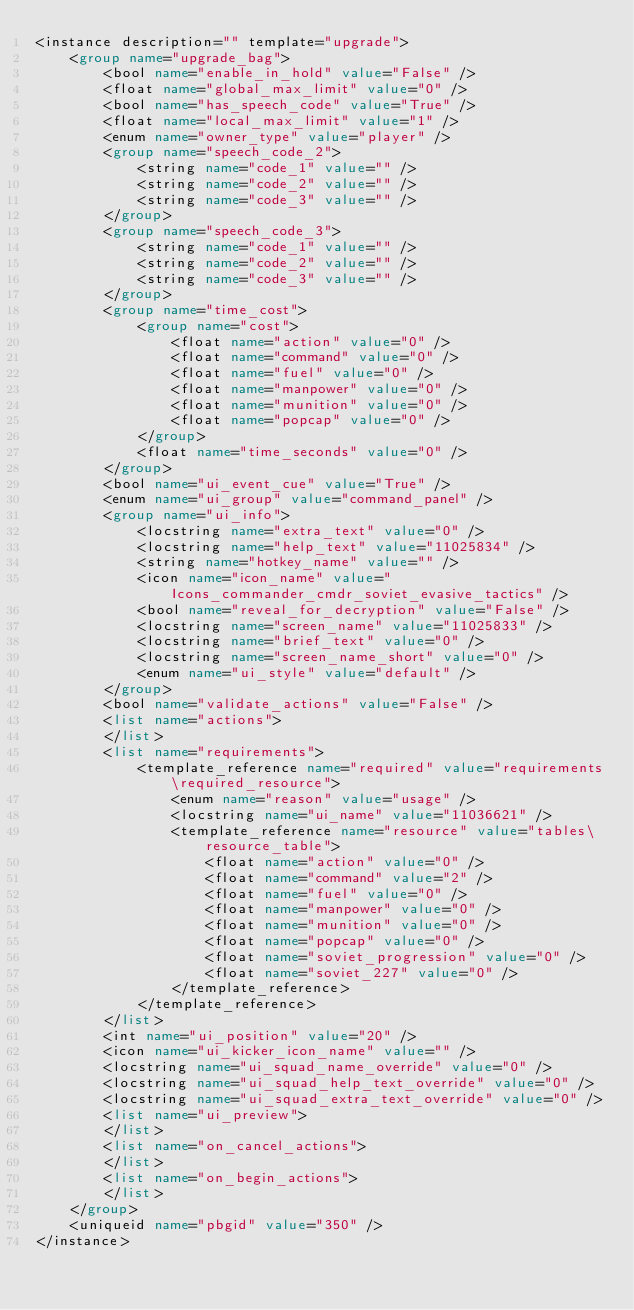<code> <loc_0><loc_0><loc_500><loc_500><_XML_><instance description="" template="upgrade">
	<group name="upgrade_bag">
		<bool name="enable_in_hold" value="False" />
		<float name="global_max_limit" value="0" />
		<bool name="has_speech_code" value="True" />
		<float name="local_max_limit" value="1" />
		<enum name="owner_type" value="player" />
		<group name="speech_code_2">
			<string name="code_1" value="" />
			<string name="code_2" value="" />
			<string name="code_3" value="" />
		</group>
		<group name="speech_code_3">
			<string name="code_1" value="" />
			<string name="code_2" value="" />
			<string name="code_3" value="" />
		</group>
		<group name="time_cost">
			<group name="cost">
				<float name="action" value="0" />
				<float name="command" value="0" />
				<float name="fuel" value="0" />
				<float name="manpower" value="0" />
				<float name="munition" value="0" />
				<float name="popcap" value="0" />
			</group>
			<float name="time_seconds" value="0" />
		</group>
		<bool name="ui_event_cue" value="True" />
		<enum name="ui_group" value="command_panel" />
		<group name="ui_info">
			<locstring name="extra_text" value="0" />
			<locstring name="help_text" value="11025834" />
			<string name="hotkey_name" value="" />
			<icon name="icon_name" value="Icons_commander_cmdr_soviet_evasive_tactics" />
			<bool name="reveal_for_decryption" value="False" />
			<locstring name="screen_name" value="11025833" />
			<locstring name="brief_text" value="0" />
			<locstring name="screen_name_short" value="0" />
			<enum name="ui_style" value="default" />
		</group>
		<bool name="validate_actions" value="False" />
		<list name="actions">
		</list>
		<list name="requirements">
			<template_reference name="required" value="requirements\required_resource">
				<enum name="reason" value="usage" />
				<locstring name="ui_name" value="11036621" />
				<template_reference name="resource" value="tables\resource_table">
					<float name="action" value="0" />
					<float name="command" value="2" />
					<float name="fuel" value="0" />
					<float name="manpower" value="0" />
					<float name="munition" value="0" />
					<float name="popcap" value="0" />
					<float name="soviet_progression" value="0" />
					<float name="soviet_227" value="0" />
				</template_reference>
			</template_reference>
		</list>
		<int name="ui_position" value="20" />
		<icon name="ui_kicker_icon_name" value="" />
		<locstring name="ui_squad_name_override" value="0" />
		<locstring name="ui_squad_help_text_override" value="0" />
		<locstring name="ui_squad_extra_text_override" value="0" />
		<list name="ui_preview">
		</list>
		<list name="on_cancel_actions">
		</list>
		<list name="on_begin_actions">
		</list>
	</group>
	<uniqueid name="pbgid" value="350" />
</instance></code> 